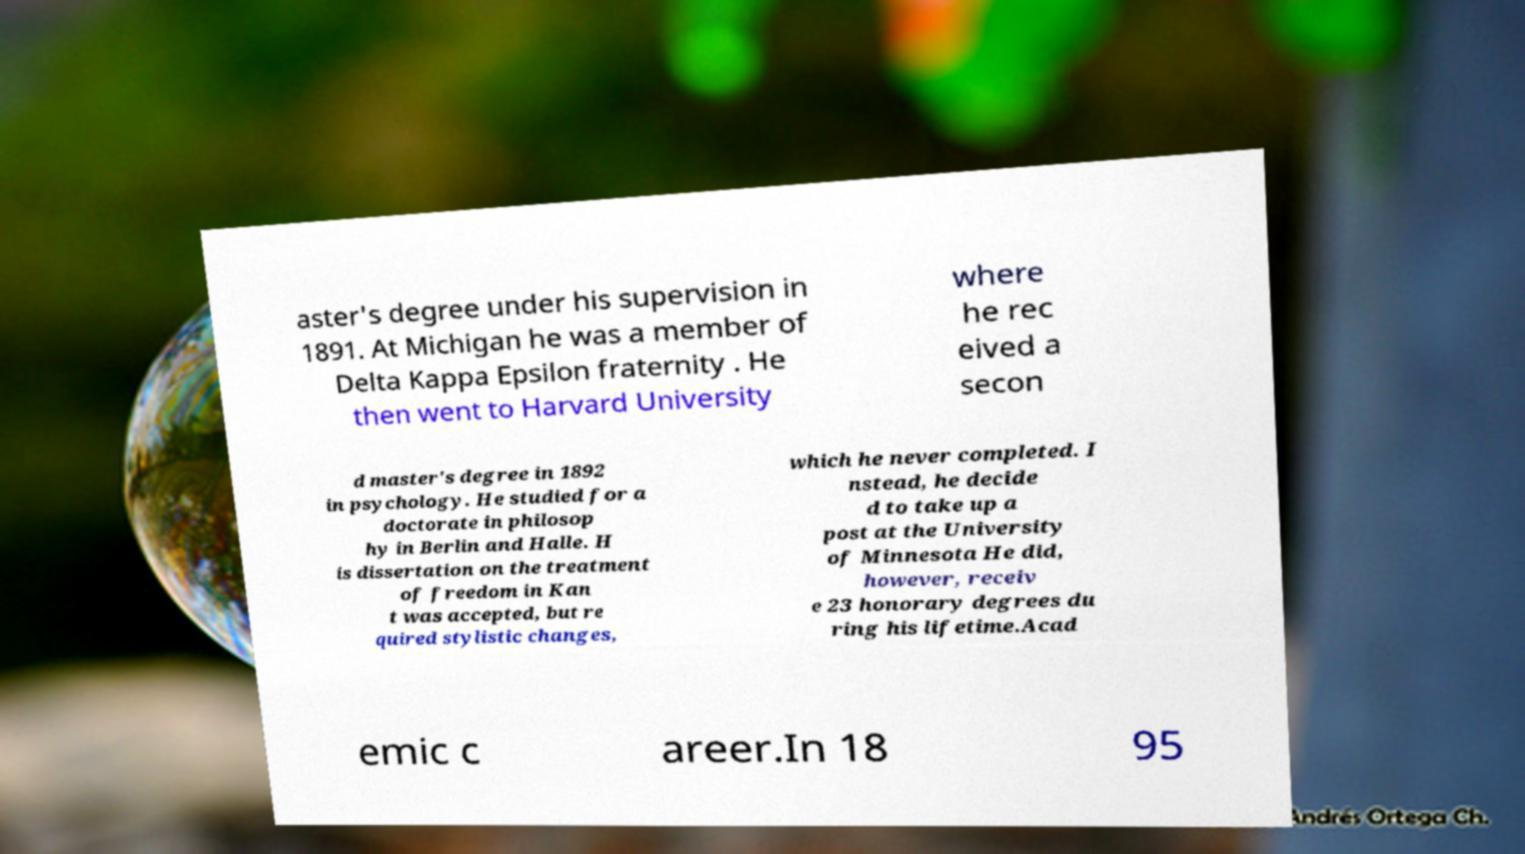Could you assist in decoding the text presented in this image and type it out clearly? aster's degree under his supervision in 1891. At Michigan he was a member of Delta Kappa Epsilon fraternity . He then went to Harvard University where he rec eived a secon d master's degree in 1892 in psychology. He studied for a doctorate in philosop hy in Berlin and Halle. H is dissertation on the treatment of freedom in Kan t was accepted, but re quired stylistic changes, which he never completed. I nstead, he decide d to take up a post at the University of Minnesota He did, however, receiv e 23 honorary degrees du ring his lifetime.Acad emic c areer.In 18 95 